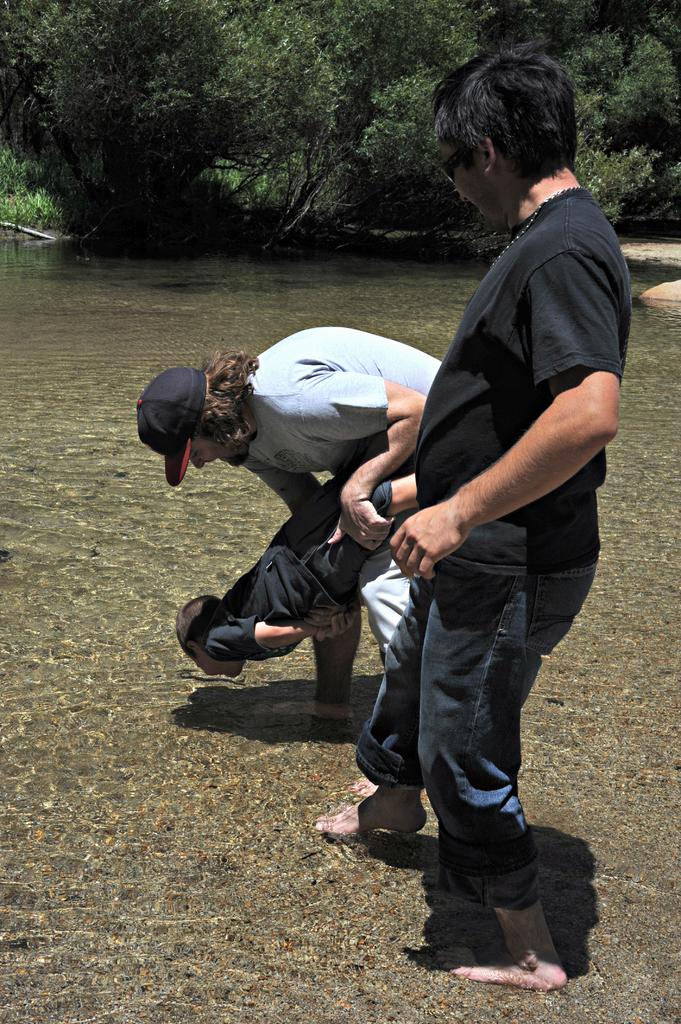What are the two men doing in the image? The two men are standing in the water. What is the man holding in his hands? The man is holding a boy in his hands. What can be seen in the background of the image? There are trees and sand visible in the background of the image. What type of lunch is being prepared on the scale in the image? There is no lunch or scale present in the image; it features two men standing in the water and a boy being held by one of them. 